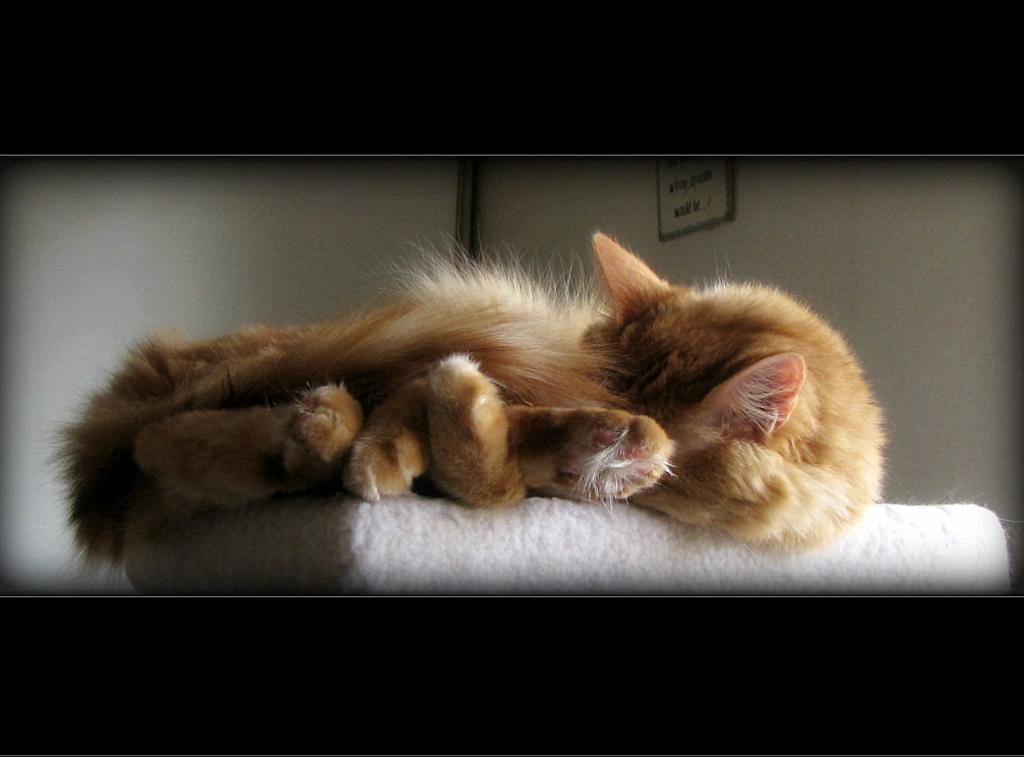What animal is present in the image? There is a cat in the image. What is the cat lying on? The cat is lying on a white surface. What can be seen in the background of the image? There is a wall with a photo frame in the background. What colors are used for the top and bottom of the image? The top and bottom of the image have a black background. What type of treatment is the cat receiving in the image? There is no indication in the image that the cat is receiving any treatment. How many copies of the cat are present in the image? There is only one cat present in the image. 